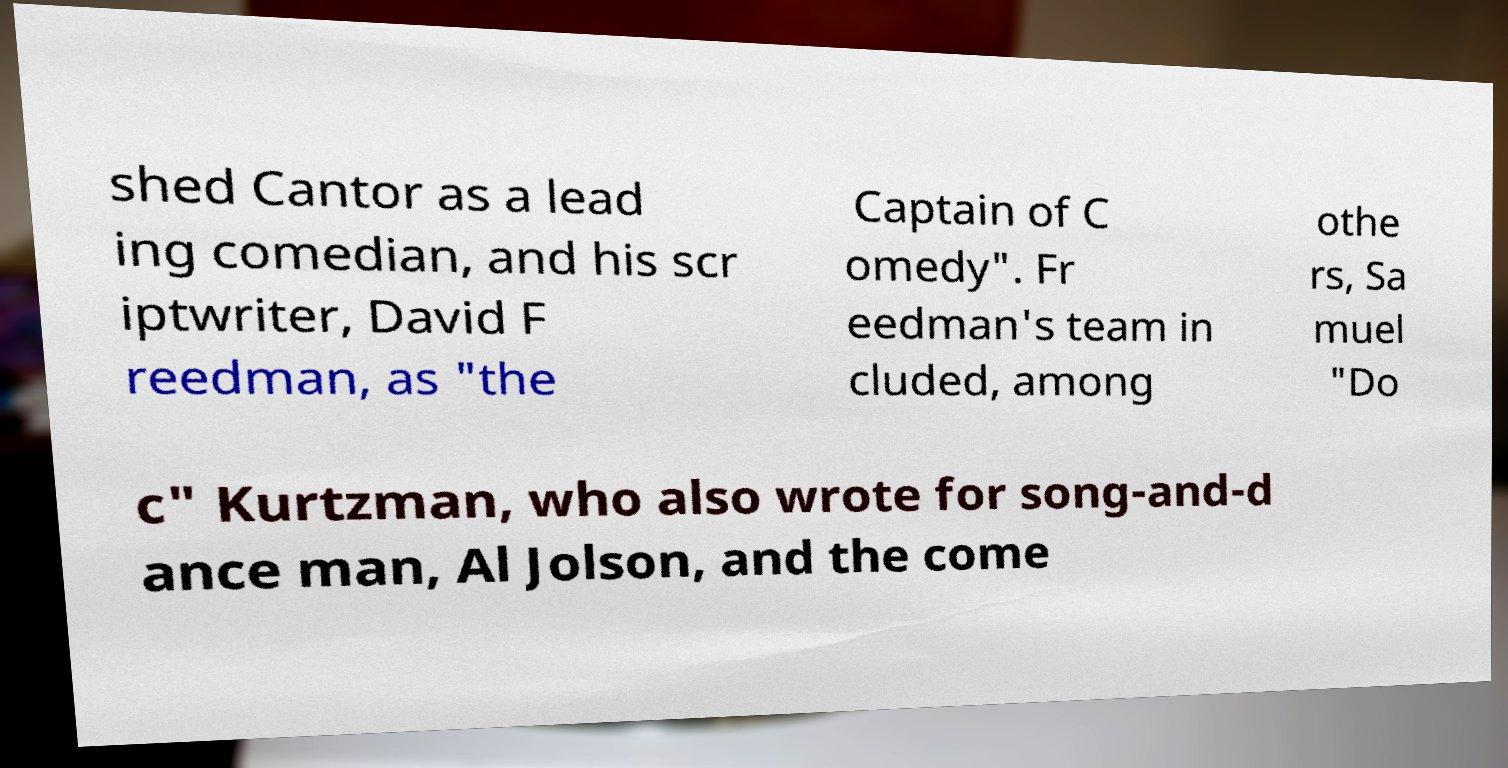There's text embedded in this image that I need extracted. Can you transcribe it verbatim? shed Cantor as a lead ing comedian, and his scr iptwriter, David F reedman, as "the Captain of C omedy". Fr eedman's team in cluded, among othe rs, Sa muel "Do c" Kurtzman, who also wrote for song-and-d ance man, Al Jolson, and the come 